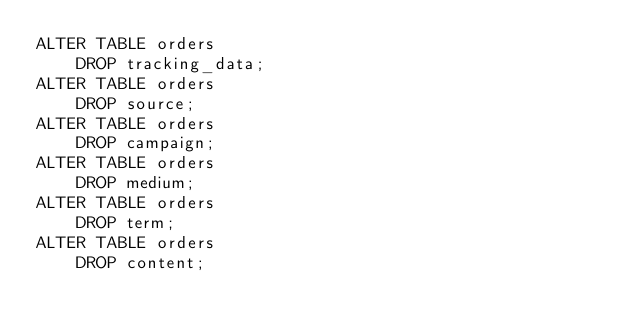Convert code to text. <code><loc_0><loc_0><loc_500><loc_500><_SQL_>ALTER TABLE orders
    DROP tracking_data;
ALTER TABLE orders
    DROP source;
ALTER TABLE orders
    DROP campaign;
ALTER TABLE orders
    DROP medium;
ALTER TABLE orders
    DROP term;
ALTER TABLE orders
    DROP content;
</code> 